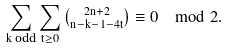Convert formula to latex. <formula><loc_0><loc_0><loc_500><loc_500>\sum _ { k \text { odd} } \sum _ { t \geq 0 } \tbinom { 2 n + 2 } { n - k - 1 - 4 t } \equiv 0 \mod 2 .</formula> 